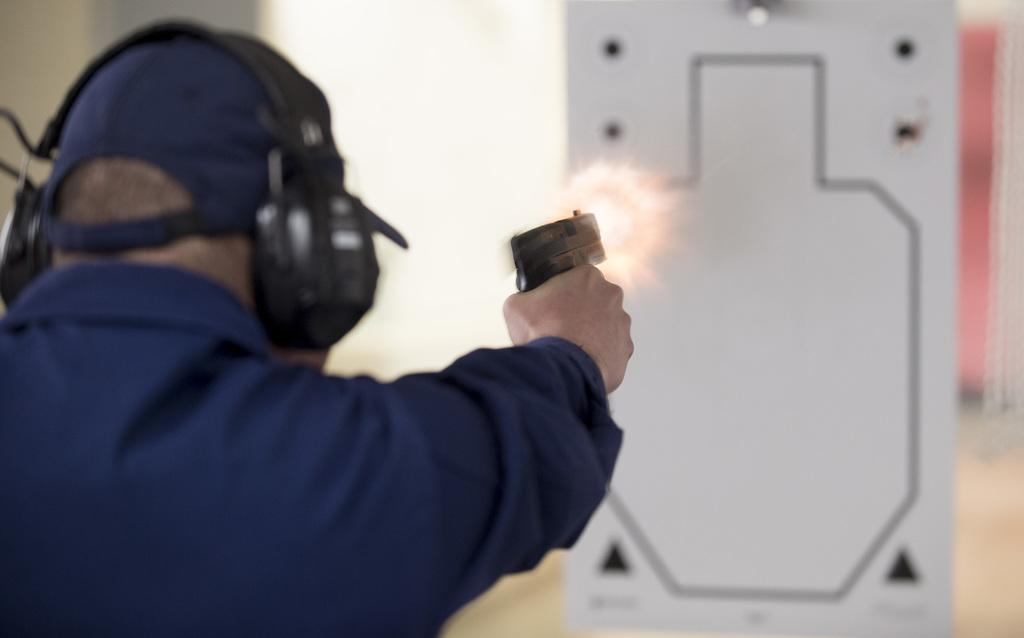Who or what is the main subject in the image? There is a person in the image. What is the person holding in the image? The person is holding a gun. What type of headgear is the person wearing? The person is wearing a cap. What type of audio equipment is the person wearing? The person is wearing headsets. Can you describe the background of the image? The background of the image is blurred. What else can be seen in the image besides the person? There is a whiteboard with figures in the image. What type of cheese is being served to the person in the image? There is no cheese present in the image. What type of servant is attending to the person in the image? There is no servant present in the image. 